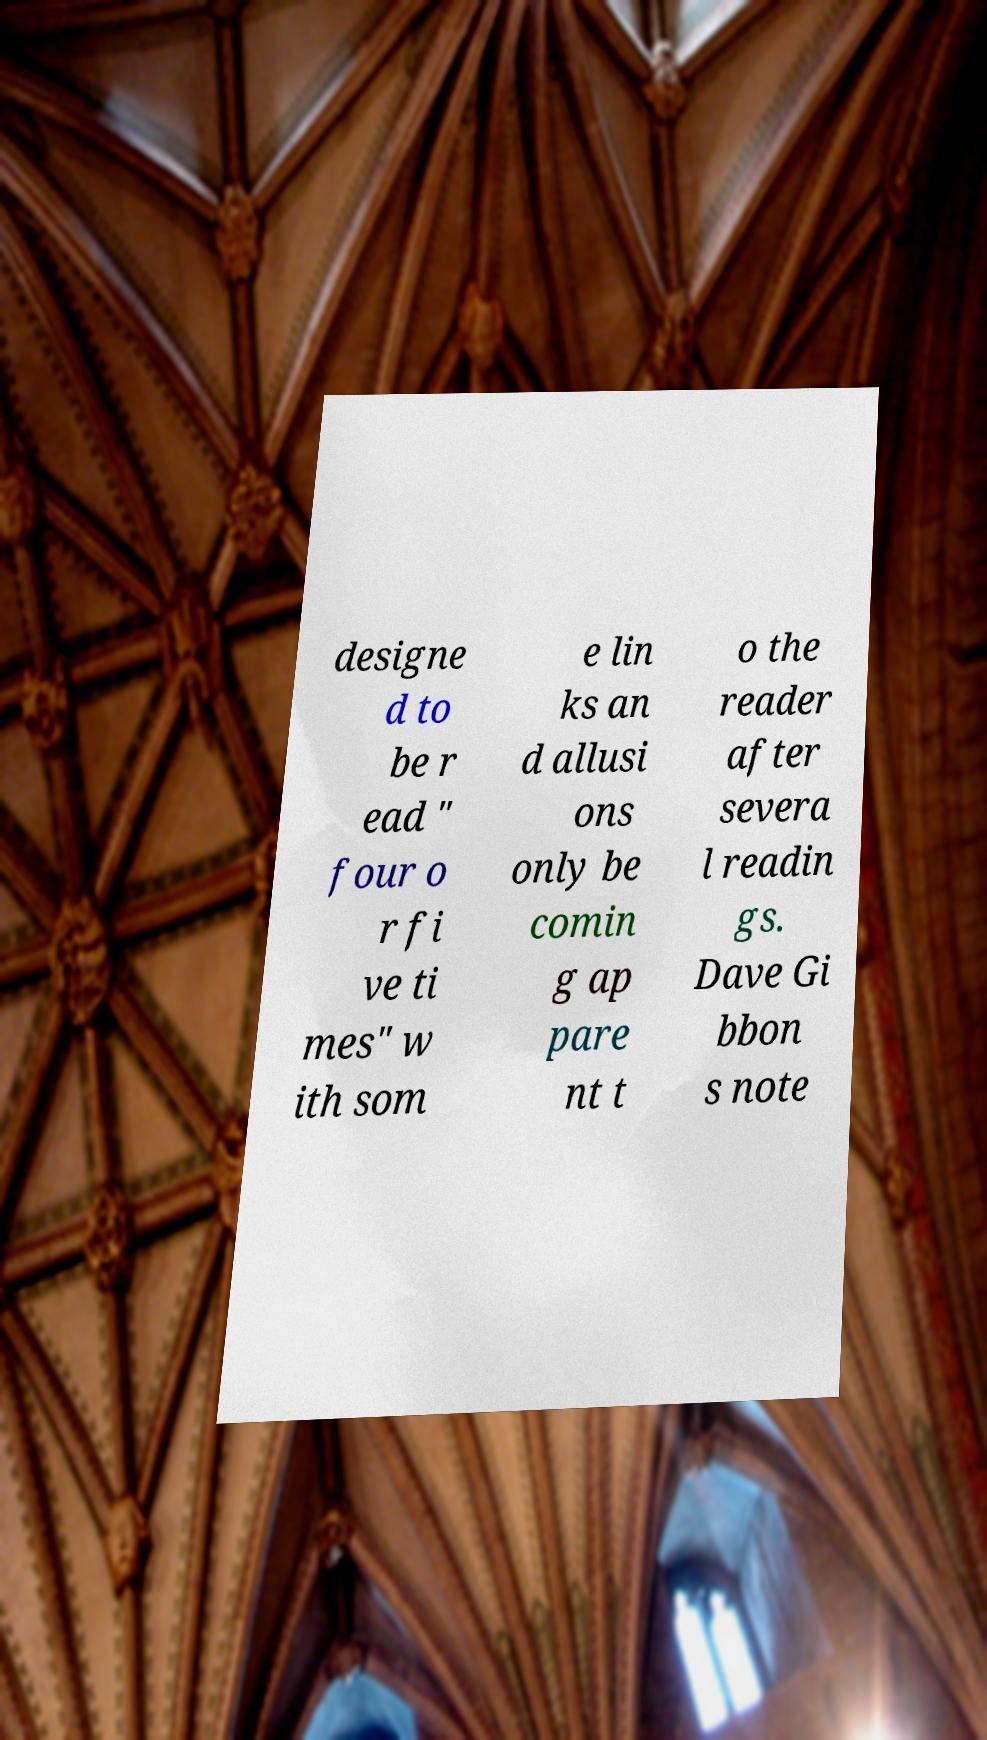Please identify and transcribe the text found in this image. designe d to be r ead " four o r fi ve ti mes" w ith som e lin ks an d allusi ons only be comin g ap pare nt t o the reader after severa l readin gs. Dave Gi bbon s note 